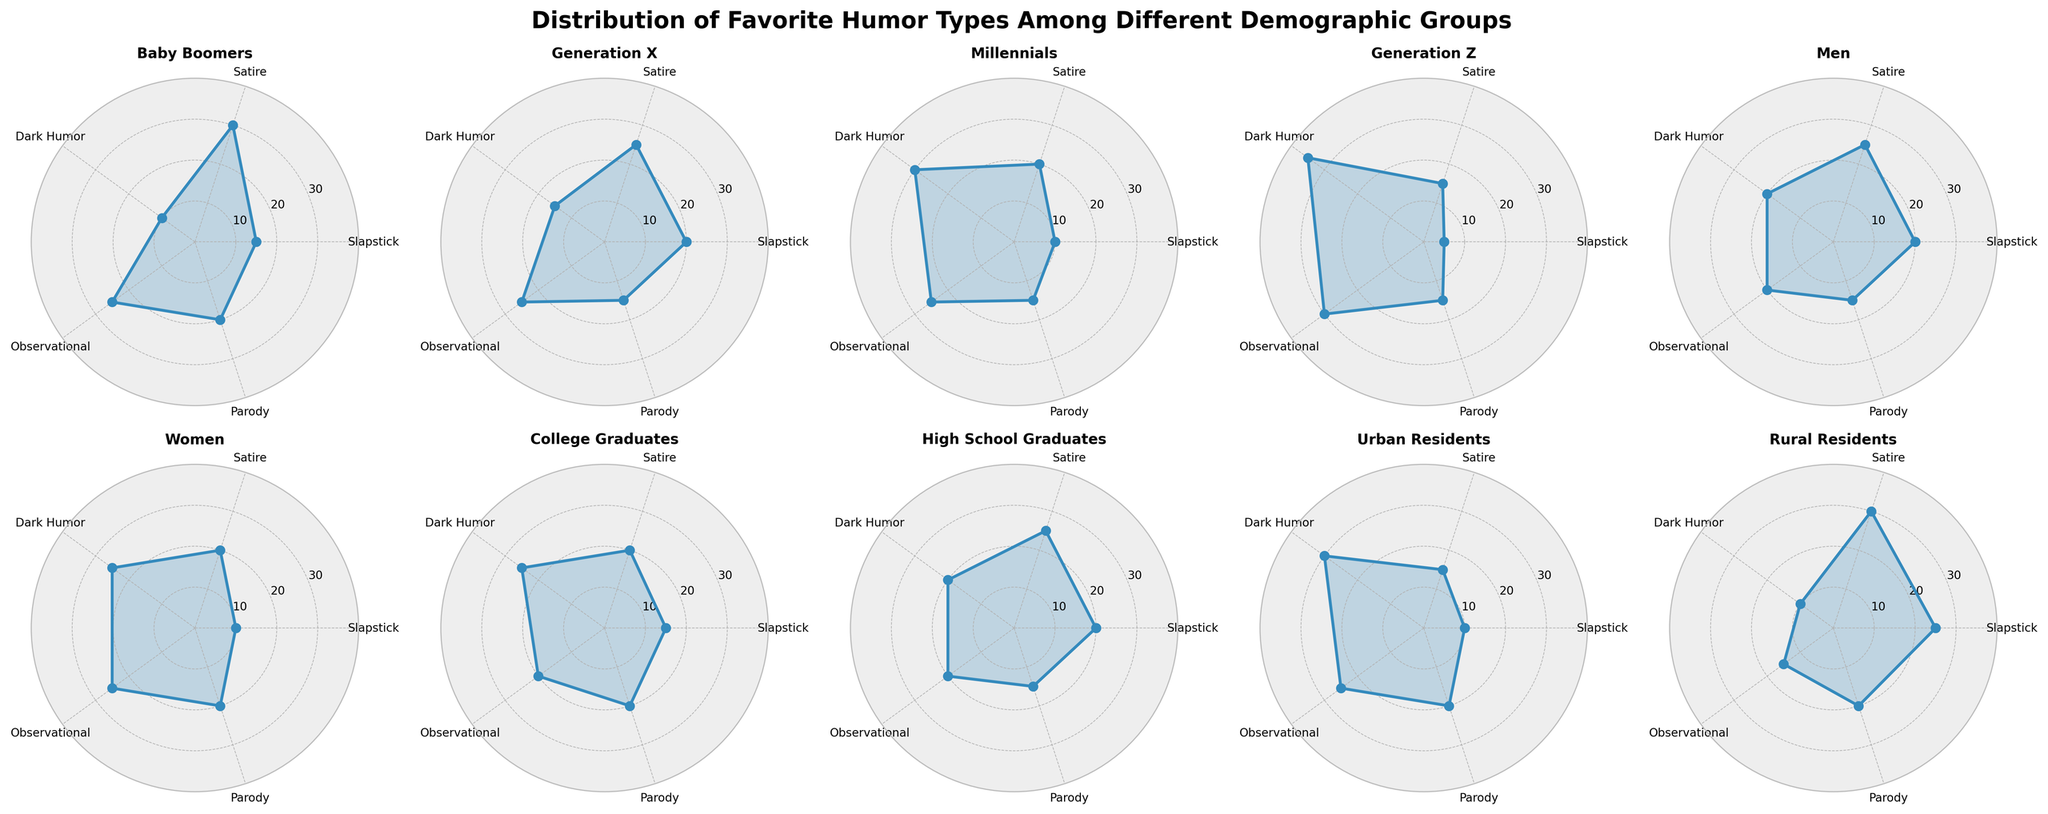What is the title of the figure? The title of the figure is generally found at the top center, displaying the main theme of the figure. It reads "Distribution of Favorite Humor Types Among Different Demographic Groups".
Answer: Distribution of Favorite Humor Types Among Different Demographic Groups Which demographic group has the highest preference for Dark Humor? By looking at the plot angles associated with each humor type for each demographic group, Generation Z has the highest value for Dark Humor, extending out to the highest point on the Dark Humor axis.
Answer: Generation Z What is the combined value of Slapstick and Parody humor preferences for Rural Residents? Find the values for Slapstick and Parody humor for Rural Residents on their respective axes. The values are 25 for Slapstick and 20 for Parody. Summing these gives 25 + 20 = 45.
Answer: 45 Which humor type has the smallest range of preference values across all demographic groups? To determine this, observe the variation in values for each humor type across all demographic plots. Observational humor has values ranging from 15 to 30, which is a range of 15, but other humor types like Dark Humor have larger ranges.
Answer: Observational Compare Men and Women in terms of their preference for Observational humor. Who prefers it more? Locate the Observational humor values for Men and Women on their respective plots. Both Men and Women have a preference value of 20 for Observational humor, so neither prefers it more than the other.
Answer: Neither Which demographic group has the widest distribution of humor type preferences? The widest distribution can be identified by observing the plots that have the most spread-out points across the axes. Generation Z shows a wide spread with Dark Humor at 35 and other humor types much lower, indicating a wide range.
Answer: Generation Z What is the median value of Satire humor preference among all demographic groups? First, list the Satire values for all groups: 30, 25, 20, 15, 25, 20, 20, 25, 15, 30. When ordered, the values are 15, 15, 20, 20, 20, 25, 25, 25, 30, 30. The median, being the middle value, is the average of the 5th and 6th values: (20 + 25) / 2 = 22.5.
Answer: 22.5 Which demographic group shows the least preference for Slapstick humor? Looking at the Slapstick values on the plots, Generation Z shows the smallest value, located at the least extension on its Slapstick axis, which is 5.
Answer: Generation Z Between Baby Boomers and Millennials, who has a higher preference for Parody humor? Compare the Parody preference values from the respective plots for these groups. Both Baby Boomers and Millennials have a Parody preference value of 15.
Answer: Both are equal For Urban Residents, what is their second most preferred humor type? By examining the plot for Urban Residents, the humor type with the second-highest value can be identified. Observational humor is the highest at 30, and Parody is the second-highest at 20.
Answer: Parody 